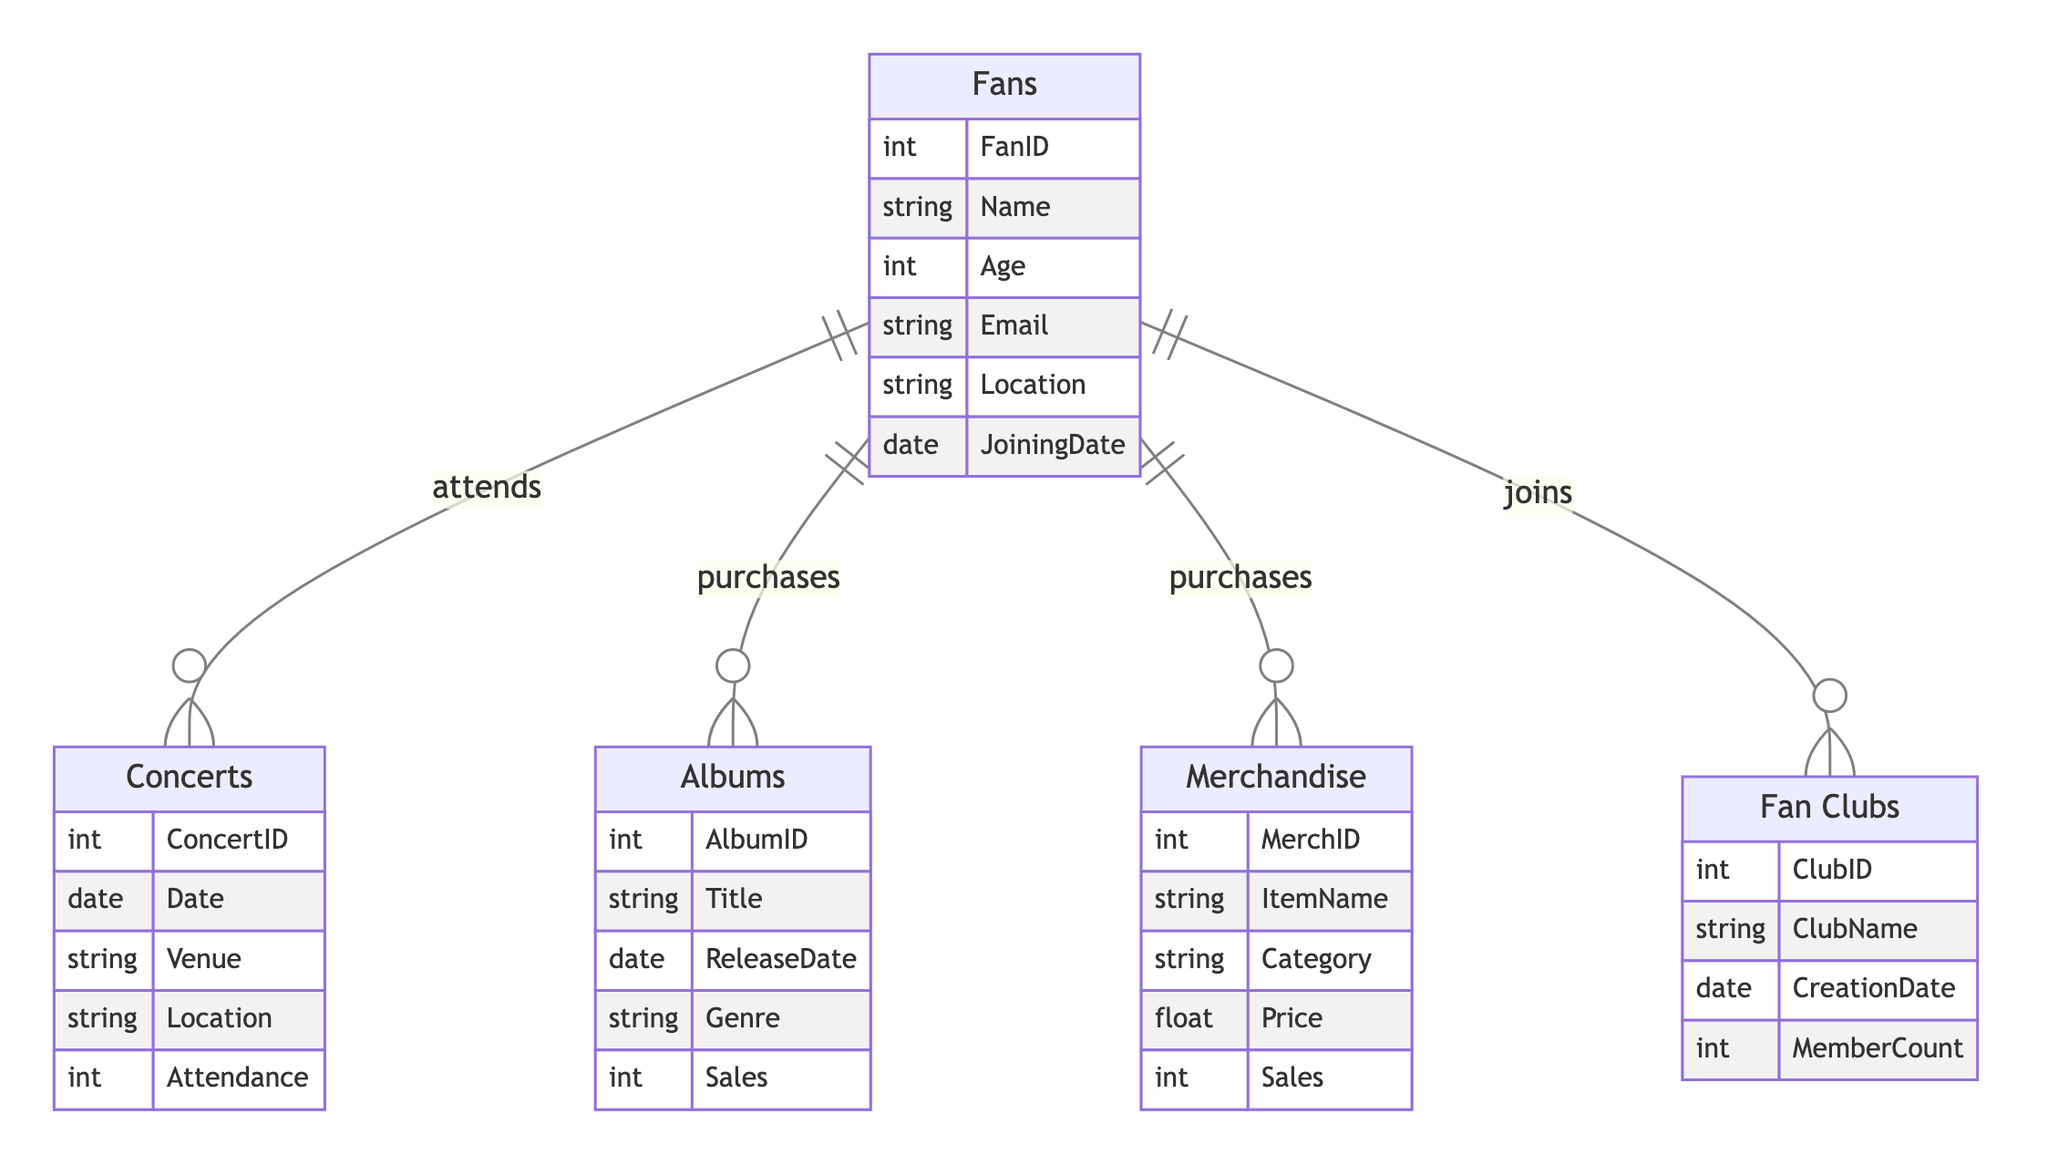What is the primary relationship between Fans and Concerts? In the diagram, the relationship is indicated by an arrow labeled "attends" that connects Fans to Concerts. This signifies that fans attend concerts, establishing a direct link between these two entities.
Answer: attends How many attributes does the Merchandise entity have? Counting the listed attributes under Merchandise in the diagram shows that there are five attributes: MerchID, ItemName, Category, Price, and Sales.
Answer: five What particular entity does a Fan join according to the diagram? The relationship diagram shows that Fans have a relationship labeled "joins" with the Fan Clubs entity, indicating that Fans can join fan clubs.
Answer: Fan Clubs Which entity tracks the attendance count at events? The Concerts entity has an attribute called Attendance, which specifically tracks the number of attendees at concerts.
Answer: Attendance If a Fan purchases both Albums and Merchandise, how many types of purchases do they make? The diagram indicates that Fans have relationships with both Albums and Merchandise labeled "purchases." Hence, if a Fan buys both, they make two types of purchases: one for Albums and one for Merchandise.
Answer: two What is the minimum number of Concerts a Fan can attend based on the relationships shown? The relationship from Fans to Concerts indicates that attending is optional; thus, the minimum number of concerts a Fan can attend is zero.
Answer: zero What type of relationship exists between Fans and Albums? The relationship represented in the diagram shows that Fans "purchase" Albums, forming a purchasing relationship between these two entities.
Answer: purchases Which entity reflects the sales figures of Albums? The Albums entity contains an attribute labeled Sales, which reflects the financial performance of the albums sold.
Answer: Sales What does the attribute "JoiningDate" in Fans signify? The JoiningDate attribute under Fans indicates the date when a fan became a member, marking their participation in the fanbase.
Answer: date of membership 